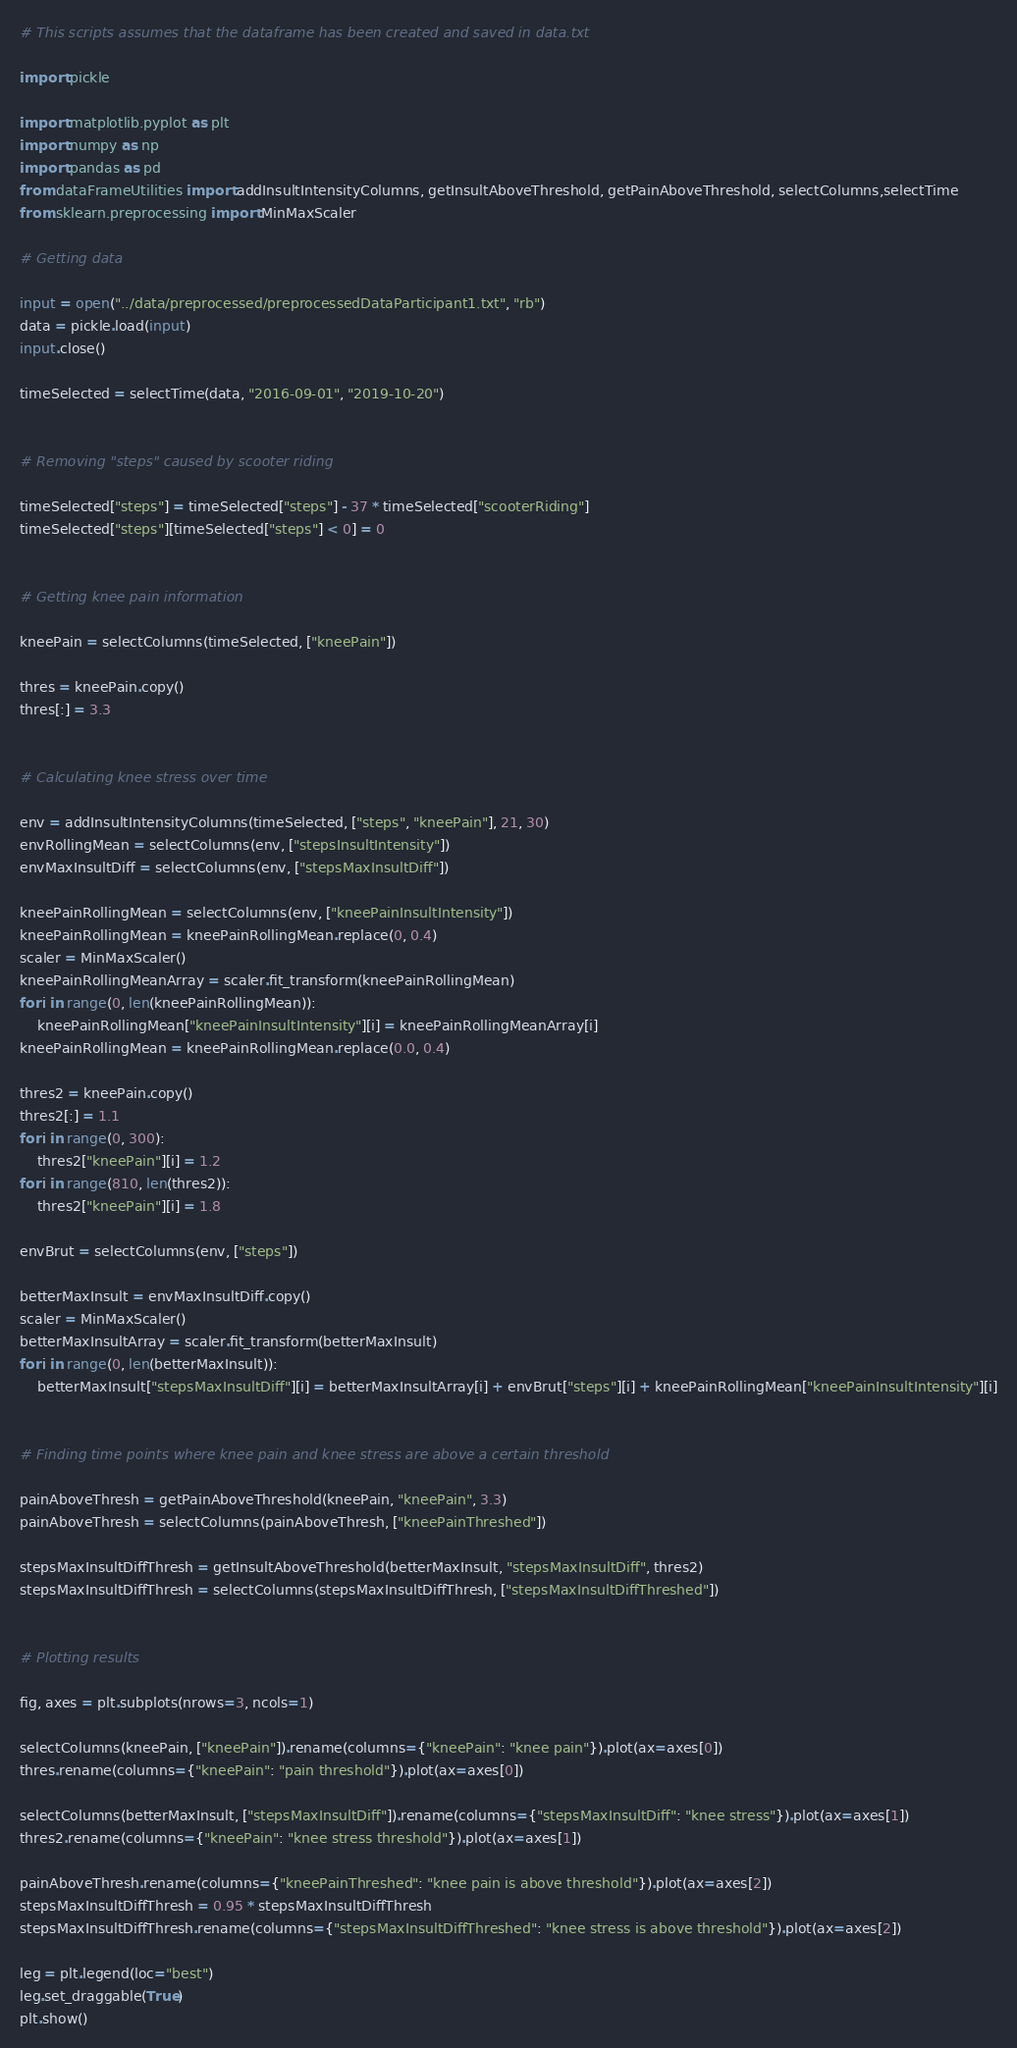Convert code to text. <code><loc_0><loc_0><loc_500><loc_500><_Python_># This scripts assumes that the dataframe has been created and saved in data.txt

import pickle

import matplotlib.pyplot as plt
import numpy as np
import pandas as pd
from dataFrameUtilities import addInsultIntensityColumns, getInsultAboveThreshold, getPainAboveThreshold, selectColumns,selectTime
from sklearn.preprocessing import MinMaxScaler

# Getting data

input = open("../data/preprocessed/preprocessedDataParticipant1.txt", "rb")
data = pickle.load(input)
input.close()

timeSelected = selectTime(data, "2016-09-01", "2019-10-20")


# Removing "steps" caused by scooter riding

timeSelected["steps"] = timeSelected["steps"] - 37 * timeSelected["scooterRiding"]
timeSelected["steps"][timeSelected["steps"] < 0] = 0


# Getting knee pain information

kneePain = selectColumns(timeSelected, ["kneePain"])

thres = kneePain.copy()
thres[:] = 3.3


# Calculating knee stress over time

env = addInsultIntensityColumns(timeSelected, ["steps", "kneePain"], 21, 30)
envRollingMean = selectColumns(env, ["stepsInsultIntensity"])
envMaxInsultDiff = selectColumns(env, ["stepsMaxInsultDiff"])

kneePainRollingMean = selectColumns(env, ["kneePainInsultIntensity"])
kneePainRollingMean = kneePainRollingMean.replace(0, 0.4)
scaler = MinMaxScaler()
kneePainRollingMeanArray = scaler.fit_transform(kneePainRollingMean)
for i in range(0, len(kneePainRollingMean)):
    kneePainRollingMean["kneePainInsultIntensity"][i] = kneePainRollingMeanArray[i]
kneePainRollingMean = kneePainRollingMean.replace(0.0, 0.4)

thres2 = kneePain.copy()
thres2[:] = 1.1
for i in range(0, 300):
    thres2["kneePain"][i] = 1.2
for i in range(810, len(thres2)):
    thres2["kneePain"][i] = 1.8

envBrut = selectColumns(env, ["steps"])

betterMaxInsult = envMaxInsultDiff.copy()
scaler = MinMaxScaler()
betterMaxInsultArray = scaler.fit_transform(betterMaxInsult)
for i in range(0, len(betterMaxInsult)):
    betterMaxInsult["stepsMaxInsultDiff"][i] = betterMaxInsultArray[i] + envBrut["steps"][i] + kneePainRollingMean["kneePainInsultIntensity"][i]


# Finding time points where knee pain and knee stress are above a certain threshold

painAboveThresh = getPainAboveThreshold(kneePain, "kneePain", 3.3)
painAboveThresh = selectColumns(painAboveThresh, ["kneePainThreshed"])

stepsMaxInsultDiffThresh = getInsultAboveThreshold(betterMaxInsult, "stepsMaxInsultDiff", thres2)
stepsMaxInsultDiffThresh = selectColumns(stepsMaxInsultDiffThresh, ["stepsMaxInsultDiffThreshed"])


# Plotting results

fig, axes = plt.subplots(nrows=3, ncols=1)

selectColumns(kneePain, ["kneePain"]).rename(columns={"kneePain": "knee pain"}).plot(ax=axes[0])
thres.rename(columns={"kneePain": "pain threshold"}).plot(ax=axes[0])

selectColumns(betterMaxInsult, ["stepsMaxInsultDiff"]).rename(columns={"stepsMaxInsultDiff": "knee stress"}).plot(ax=axes[1])
thres2.rename(columns={"kneePain": "knee stress threshold"}).plot(ax=axes[1])

painAboveThresh.rename(columns={"kneePainThreshed": "knee pain is above threshold"}).plot(ax=axes[2])
stepsMaxInsultDiffThresh = 0.95 * stepsMaxInsultDiffThresh
stepsMaxInsultDiffThresh.rename(columns={"stepsMaxInsultDiffThreshed": "knee stress is above threshold"}).plot(ax=axes[2])

leg = plt.legend(loc="best")
leg.set_draggable(True)
plt.show()
</code> 